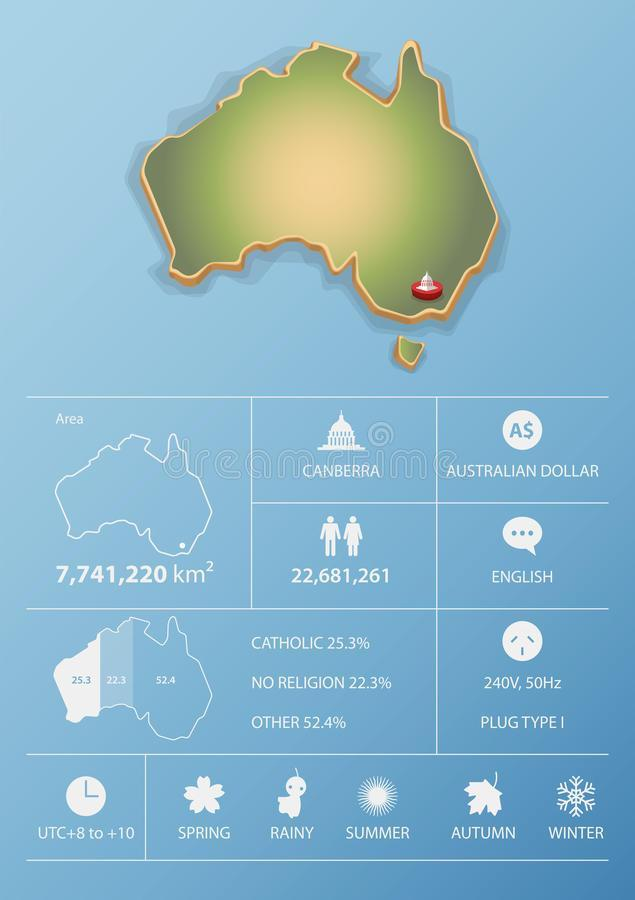How many seasons are mentioned in the image ?
Answer the question with a short phrase. 5 